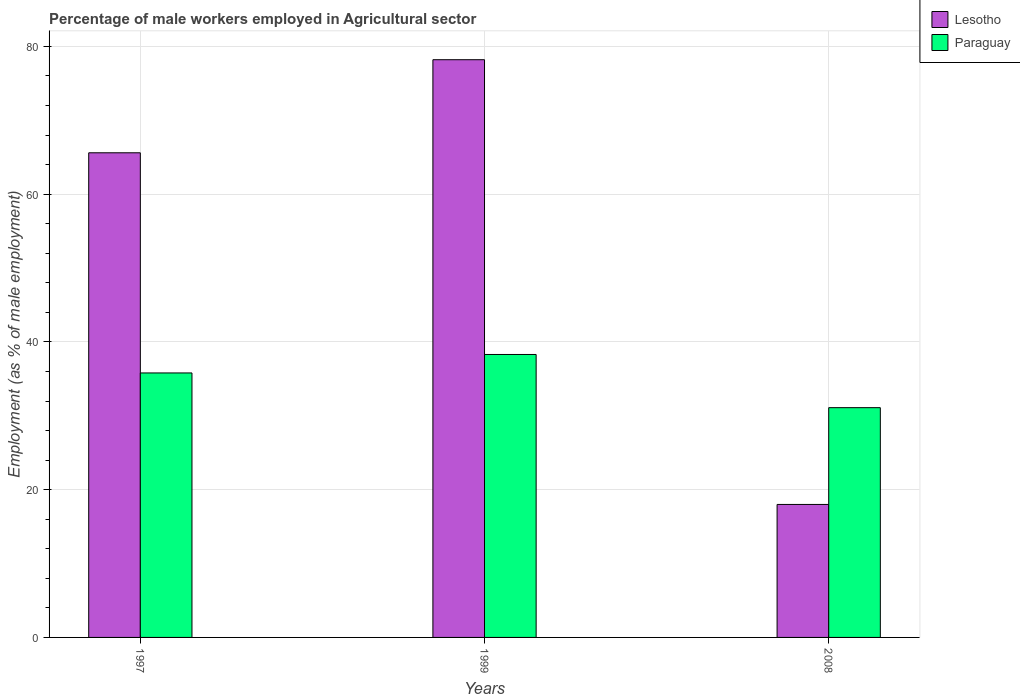How many different coloured bars are there?
Offer a very short reply. 2. How many groups of bars are there?
Keep it short and to the point. 3. Are the number of bars per tick equal to the number of legend labels?
Your answer should be very brief. Yes. How many bars are there on the 3rd tick from the left?
Ensure brevity in your answer.  2. What is the percentage of male workers employed in Agricultural sector in Paraguay in 1999?
Your answer should be very brief. 38.3. Across all years, what is the maximum percentage of male workers employed in Agricultural sector in Paraguay?
Provide a short and direct response. 38.3. Across all years, what is the minimum percentage of male workers employed in Agricultural sector in Paraguay?
Your response must be concise. 31.1. What is the total percentage of male workers employed in Agricultural sector in Lesotho in the graph?
Provide a short and direct response. 161.8. What is the difference between the percentage of male workers employed in Agricultural sector in Paraguay in 1997 and that in 1999?
Provide a short and direct response. -2.5. What is the difference between the percentage of male workers employed in Agricultural sector in Lesotho in 2008 and the percentage of male workers employed in Agricultural sector in Paraguay in 1997?
Offer a terse response. -17.8. What is the average percentage of male workers employed in Agricultural sector in Paraguay per year?
Your answer should be compact. 35.07. In the year 2008, what is the difference between the percentage of male workers employed in Agricultural sector in Lesotho and percentage of male workers employed in Agricultural sector in Paraguay?
Offer a very short reply. -13.1. What is the ratio of the percentage of male workers employed in Agricultural sector in Paraguay in 1997 to that in 2008?
Make the answer very short. 1.15. What is the difference between the highest and the second highest percentage of male workers employed in Agricultural sector in Lesotho?
Offer a terse response. 12.6. What is the difference between the highest and the lowest percentage of male workers employed in Agricultural sector in Lesotho?
Your answer should be very brief. 60.2. In how many years, is the percentage of male workers employed in Agricultural sector in Lesotho greater than the average percentage of male workers employed in Agricultural sector in Lesotho taken over all years?
Your answer should be very brief. 2. Is the sum of the percentage of male workers employed in Agricultural sector in Lesotho in 1997 and 1999 greater than the maximum percentage of male workers employed in Agricultural sector in Paraguay across all years?
Offer a very short reply. Yes. What does the 2nd bar from the left in 1999 represents?
Your response must be concise. Paraguay. What does the 2nd bar from the right in 1997 represents?
Provide a succinct answer. Lesotho. Are all the bars in the graph horizontal?
Keep it short and to the point. No. How many years are there in the graph?
Your answer should be very brief. 3. Are the values on the major ticks of Y-axis written in scientific E-notation?
Offer a very short reply. No. Does the graph contain any zero values?
Give a very brief answer. No. Where does the legend appear in the graph?
Keep it short and to the point. Top right. How many legend labels are there?
Keep it short and to the point. 2. How are the legend labels stacked?
Keep it short and to the point. Vertical. What is the title of the graph?
Provide a short and direct response. Percentage of male workers employed in Agricultural sector. What is the label or title of the X-axis?
Provide a short and direct response. Years. What is the label or title of the Y-axis?
Offer a terse response. Employment (as % of male employment). What is the Employment (as % of male employment) of Lesotho in 1997?
Keep it short and to the point. 65.6. What is the Employment (as % of male employment) in Paraguay in 1997?
Your answer should be very brief. 35.8. What is the Employment (as % of male employment) of Lesotho in 1999?
Your answer should be very brief. 78.2. What is the Employment (as % of male employment) in Paraguay in 1999?
Your answer should be compact. 38.3. What is the Employment (as % of male employment) in Lesotho in 2008?
Provide a succinct answer. 18. What is the Employment (as % of male employment) of Paraguay in 2008?
Provide a short and direct response. 31.1. Across all years, what is the maximum Employment (as % of male employment) in Lesotho?
Ensure brevity in your answer.  78.2. Across all years, what is the maximum Employment (as % of male employment) of Paraguay?
Offer a terse response. 38.3. Across all years, what is the minimum Employment (as % of male employment) in Paraguay?
Provide a succinct answer. 31.1. What is the total Employment (as % of male employment) of Lesotho in the graph?
Provide a succinct answer. 161.8. What is the total Employment (as % of male employment) of Paraguay in the graph?
Your answer should be very brief. 105.2. What is the difference between the Employment (as % of male employment) in Lesotho in 1997 and that in 1999?
Give a very brief answer. -12.6. What is the difference between the Employment (as % of male employment) in Paraguay in 1997 and that in 1999?
Ensure brevity in your answer.  -2.5. What is the difference between the Employment (as % of male employment) in Lesotho in 1997 and that in 2008?
Your answer should be very brief. 47.6. What is the difference between the Employment (as % of male employment) of Lesotho in 1999 and that in 2008?
Provide a succinct answer. 60.2. What is the difference between the Employment (as % of male employment) in Paraguay in 1999 and that in 2008?
Offer a very short reply. 7.2. What is the difference between the Employment (as % of male employment) of Lesotho in 1997 and the Employment (as % of male employment) of Paraguay in 1999?
Give a very brief answer. 27.3. What is the difference between the Employment (as % of male employment) of Lesotho in 1997 and the Employment (as % of male employment) of Paraguay in 2008?
Give a very brief answer. 34.5. What is the difference between the Employment (as % of male employment) in Lesotho in 1999 and the Employment (as % of male employment) in Paraguay in 2008?
Give a very brief answer. 47.1. What is the average Employment (as % of male employment) in Lesotho per year?
Provide a succinct answer. 53.93. What is the average Employment (as % of male employment) in Paraguay per year?
Provide a short and direct response. 35.07. In the year 1997, what is the difference between the Employment (as % of male employment) in Lesotho and Employment (as % of male employment) in Paraguay?
Keep it short and to the point. 29.8. In the year 1999, what is the difference between the Employment (as % of male employment) in Lesotho and Employment (as % of male employment) in Paraguay?
Give a very brief answer. 39.9. In the year 2008, what is the difference between the Employment (as % of male employment) in Lesotho and Employment (as % of male employment) in Paraguay?
Your answer should be very brief. -13.1. What is the ratio of the Employment (as % of male employment) in Lesotho in 1997 to that in 1999?
Provide a short and direct response. 0.84. What is the ratio of the Employment (as % of male employment) in Paraguay in 1997 to that in 1999?
Provide a succinct answer. 0.93. What is the ratio of the Employment (as % of male employment) in Lesotho in 1997 to that in 2008?
Provide a succinct answer. 3.64. What is the ratio of the Employment (as % of male employment) in Paraguay in 1997 to that in 2008?
Ensure brevity in your answer.  1.15. What is the ratio of the Employment (as % of male employment) of Lesotho in 1999 to that in 2008?
Provide a short and direct response. 4.34. What is the ratio of the Employment (as % of male employment) in Paraguay in 1999 to that in 2008?
Your answer should be very brief. 1.23. What is the difference between the highest and the second highest Employment (as % of male employment) in Paraguay?
Your answer should be very brief. 2.5. What is the difference between the highest and the lowest Employment (as % of male employment) of Lesotho?
Make the answer very short. 60.2. 